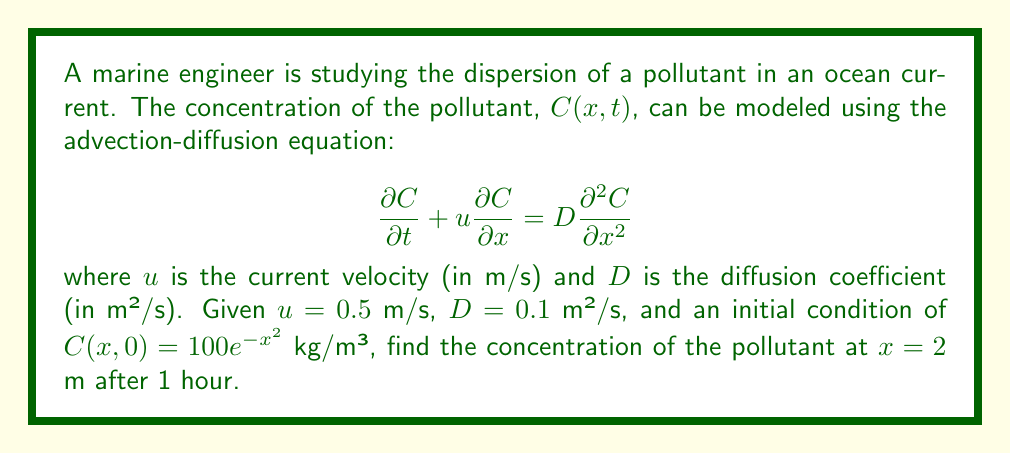Teach me how to tackle this problem. To solve this problem, we can use the analytical solution of the advection-diffusion equation for an instantaneous point source in an infinite domain:

$$C(x,t) = \frac{M}{\sqrt{4\pi Dt}} \exp\left(-\frac{(x-ut)^2}{4Dt}\right)$$

where $M$ is the total mass of the pollutant per unit cross-sectional area.

Step 1: Determine $M$ from the initial condition.
$$M = \int_{-\infty}^{\infty} C(x,0) dx = \int_{-\infty}^{\infty} 100e^{-x^2} dx = 100\sqrt{\pi}$$

Step 2: Substitute the given values into the solution equation.
$x = 2$ m
$t = 1$ hour = 3600 s
$u = 0.5$ m/s
$D = 0.1$ m²/s
$M = 100\sqrt{\pi}$ kg/m²

$$C(2,3600) = \frac{100\sqrt{\pi}}{\sqrt{4\pi(0.1)(3600)}} \exp\left(-\frac{(2-0.5(3600))^2}{4(0.1)(3600)}\right)$$

Step 3: Simplify and calculate.
$$C(2,3600) = \frac{100}{\sqrt{144}} \exp\left(-\frac{(2-1800)^2}{1440}\right)$$
$$C(2,3600) = 8.33 \exp\left(-\frac{3240004}{1440}\right)$$
$$C(2,3600) \approx 0$$

The concentration is effectively zero due to the large negative exponent.
Answer: 0 kg/m³ 